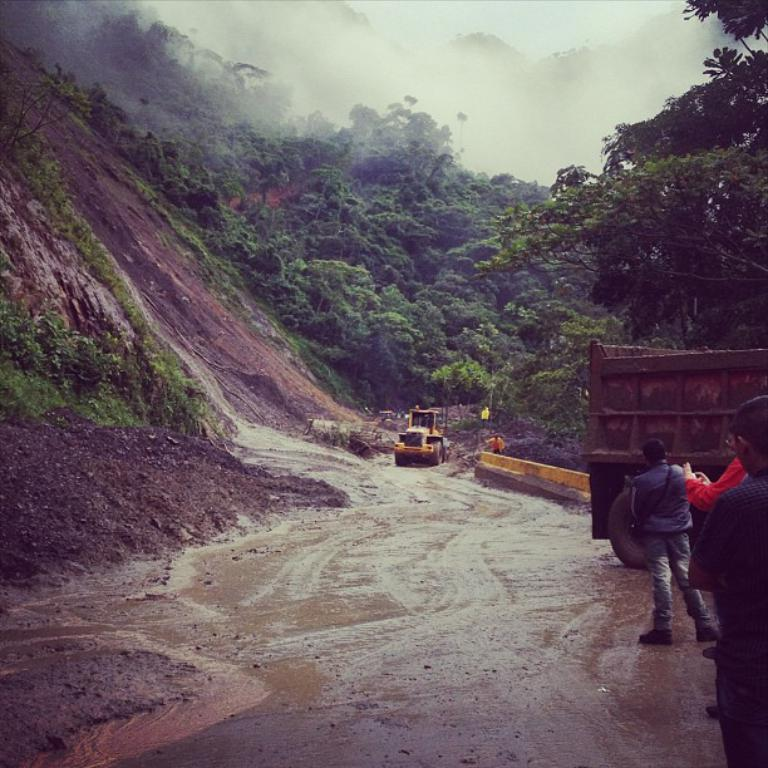Who or what can be seen in the image? There are people in the image. What else is visible on the road in the image? There are two vehicles on the road. What type of natural features can be seen in the image? Mountains and trees are visible in the image. What is the condition of the sky in the image? The sky is cloudy and visible at the top of the image. What part of the vehicle is the manager sitting in? There is no mention of a manager or a specific part of a vehicle in the image. 